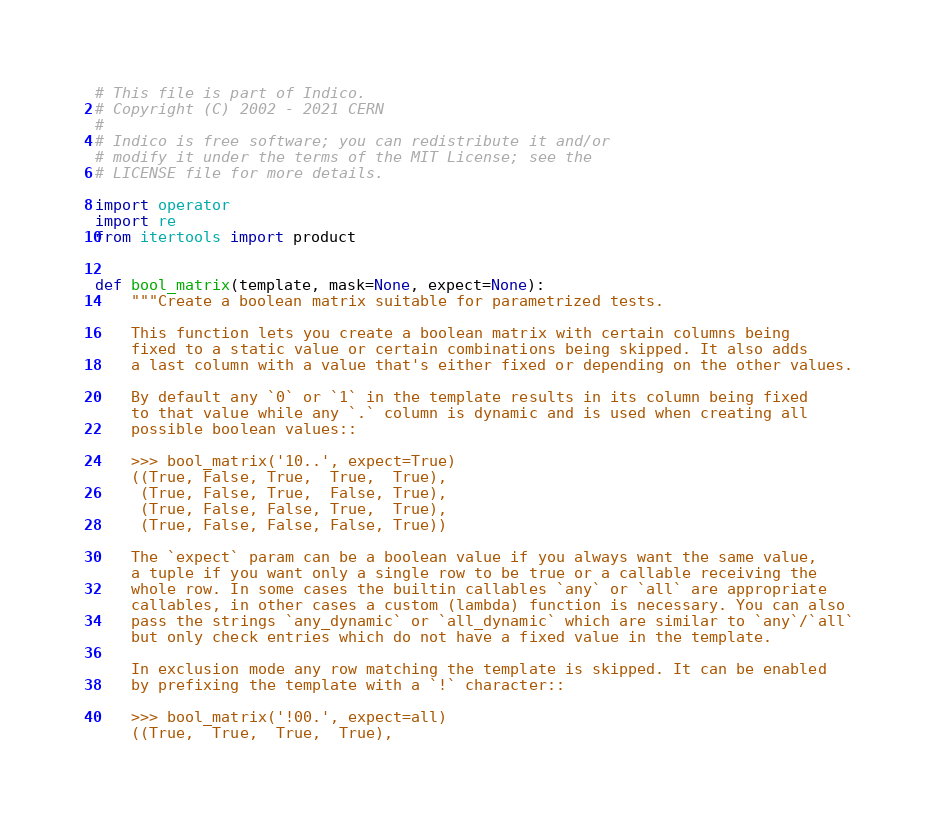<code> <loc_0><loc_0><loc_500><loc_500><_Python_># This file is part of Indico.
# Copyright (C) 2002 - 2021 CERN
#
# Indico is free software; you can redistribute it and/or
# modify it under the terms of the MIT License; see the
# LICENSE file for more details.

import operator
import re
from itertools import product


def bool_matrix(template, mask=None, expect=None):
    """Create a boolean matrix suitable for parametrized tests.

    This function lets you create a boolean matrix with certain columns being
    fixed to a static value or certain combinations being skipped. It also adds
    a last column with a value that's either fixed or depending on the other values.

    By default any `0` or `1` in the template results in its column being fixed
    to that value while any `.` column is dynamic and is used when creating all
    possible boolean values::

    >>> bool_matrix('10..', expect=True)
    ((True, False, True,  True,  True),
     (True, False, True,  False, True),
     (True, False, False, True,  True),
     (True, False, False, False, True))

    The `expect` param can be a boolean value if you always want the same value,
    a tuple if you want only a single row to be true or a callable receiving the
    whole row. In some cases the builtin callables `any` or `all` are appropriate
    callables, in other cases a custom (lambda) function is necessary. You can also
    pass the strings `any_dynamic` or `all_dynamic` which are similar to `any`/`all`
    but only check entries which do not have a fixed value in the template.

    In exclusion mode any row matching the template is skipped. It can be enabled
    by prefixing the template with a `!` character::

    >>> bool_matrix('!00.', expect=all)
    ((True,  True,  True,  True),</code> 